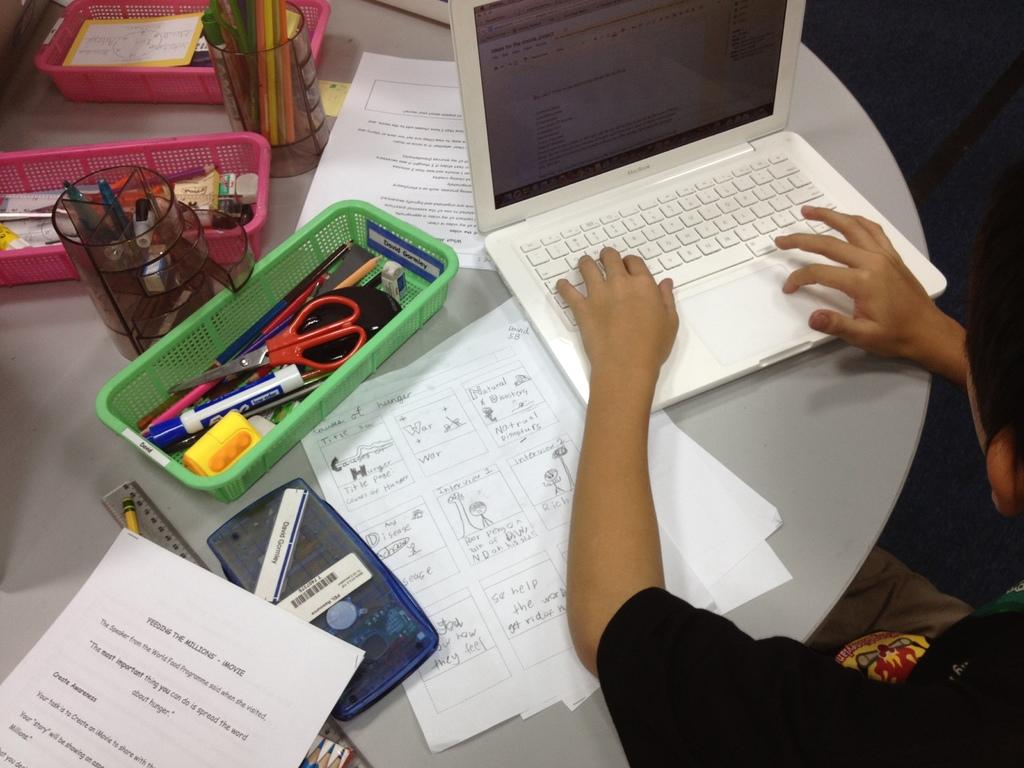<image>
Create a compact narrative representing the image presented. An overview of a lady on her laptop with a paper titled feeding the millions. 